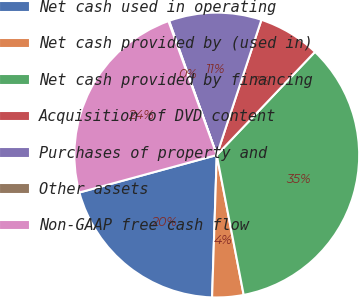Convert chart to OTSL. <chart><loc_0><loc_0><loc_500><loc_500><pie_chart><fcel>Net cash used in operating<fcel>Net cash provided by (used in)<fcel>Net cash provided by financing<fcel>Acquisition of DVD content<fcel>Purchases of property and<fcel>Other assets<fcel>Non-GAAP free cash flow<nl><fcel>20.24%<fcel>3.55%<fcel>34.87%<fcel>7.03%<fcel>10.51%<fcel>0.08%<fcel>23.72%<nl></chart> 